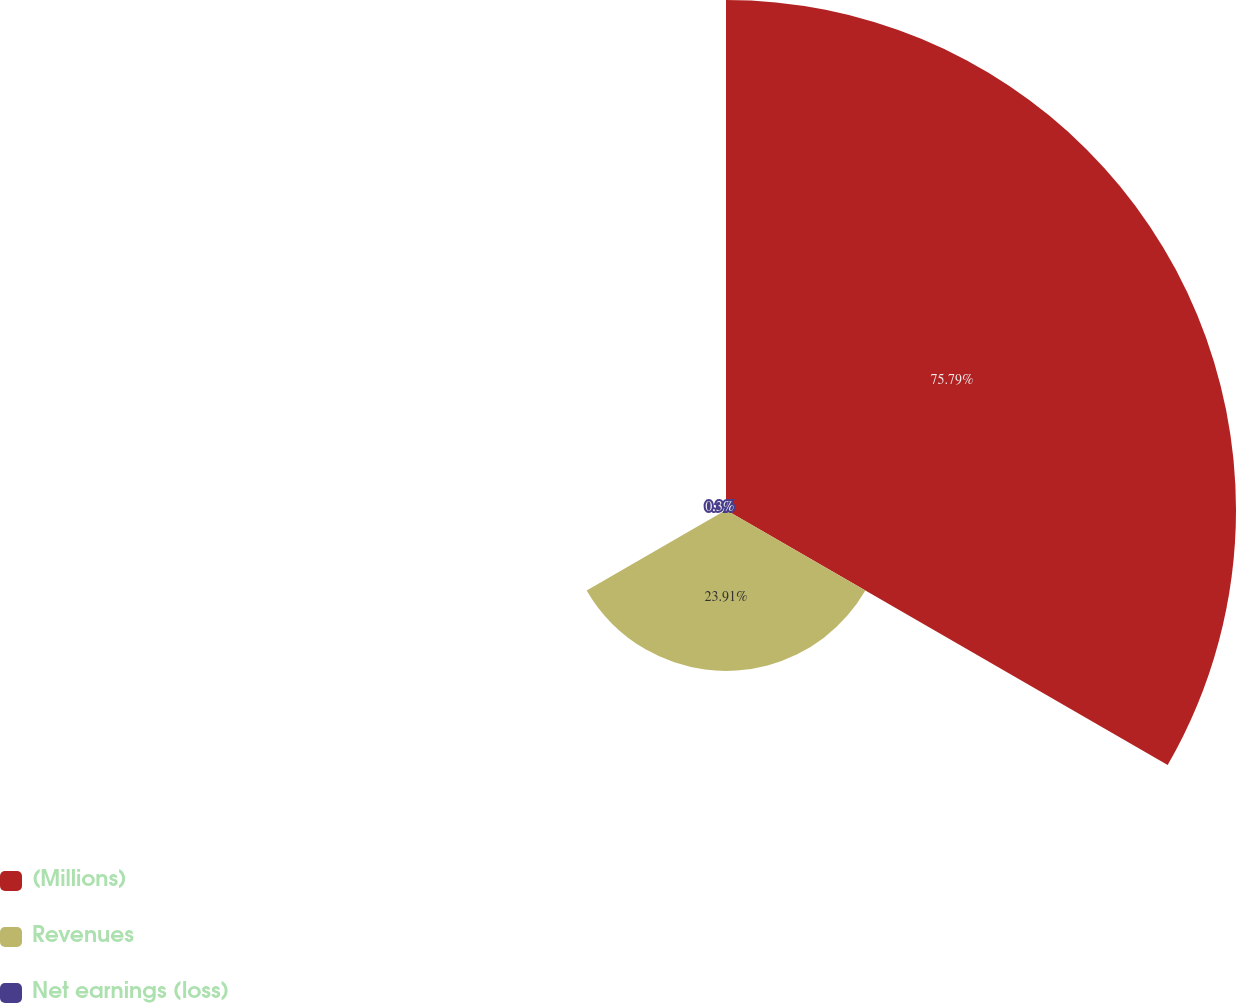Convert chart to OTSL. <chart><loc_0><loc_0><loc_500><loc_500><pie_chart><fcel>(Millions)<fcel>Revenues<fcel>Net earnings (loss)<nl><fcel>75.79%<fcel>23.91%<fcel>0.3%<nl></chart> 